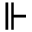<formula> <loc_0><loc_0><loc_500><loc_500>\ V d a s h</formula> 